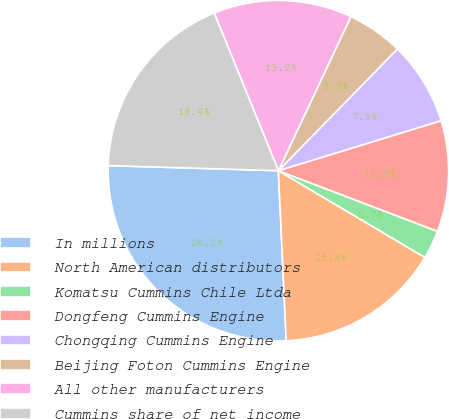Convert chart to OTSL. <chart><loc_0><loc_0><loc_500><loc_500><pie_chart><fcel>In millions<fcel>North American distributors<fcel>Komatsu Cummins Chile Ltda<fcel>Dongfeng Cummins Engine<fcel>Chongqing Cummins Engine<fcel>Beijing Foton Cummins Engine<fcel>All other manufacturers<fcel>Cummins share of net income<nl><fcel>26.2%<fcel>15.76%<fcel>2.71%<fcel>10.54%<fcel>7.93%<fcel>5.32%<fcel>13.15%<fcel>18.37%<nl></chart> 